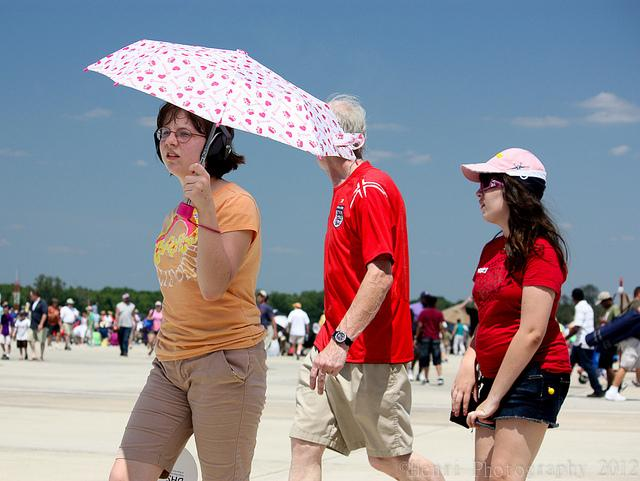The person holding the umbrella looks most like who? girl 